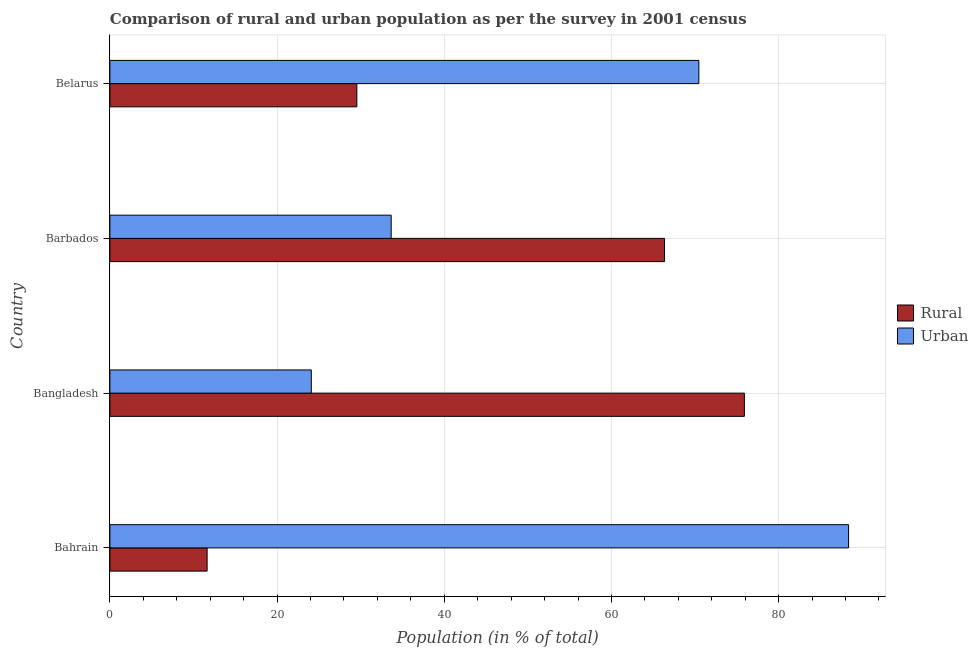Are the number of bars on each tick of the Y-axis equal?
Give a very brief answer. Yes. What is the label of the 1st group of bars from the top?
Provide a succinct answer. Belarus. In how many cases, is the number of bars for a given country not equal to the number of legend labels?
Ensure brevity in your answer.  0. What is the rural population in Bahrain?
Offer a very short reply. 11.63. Across all countries, what is the maximum urban population?
Your answer should be very brief. 88.37. Across all countries, what is the minimum rural population?
Offer a very short reply. 11.63. In which country was the urban population maximum?
Keep it short and to the point. Bahrain. In which country was the rural population minimum?
Your response must be concise. Bahrain. What is the total rural population in the graph?
Keep it short and to the point. 183.43. What is the difference between the urban population in Barbados and that in Belarus?
Provide a succinct answer. -36.81. What is the difference between the urban population in Bangladesh and the rural population in Barbados?
Your answer should be very brief. -42.25. What is the average rural population per country?
Make the answer very short. 45.86. What is the difference between the urban population and rural population in Bangladesh?
Provide a short and direct response. -51.81. What is the ratio of the urban population in Bahrain to that in Bangladesh?
Give a very brief answer. 3.67. Is the urban population in Bangladesh less than that in Belarus?
Your answer should be very brief. Yes. What is the difference between the highest and the second highest urban population?
Provide a short and direct response. 17.91. What is the difference between the highest and the lowest urban population?
Keep it short and to the point. 64.27. What does the 1st bar from the top in Belarus represents?
Your response must be concise. Urban. What does the 2nd bar from the bottom in Barbados represents?
Make the answer very short. Urban. How many bars are there?
Your answer should be compact. 8. Where does the legend appear in the graph?
Make the answer very short. Center right. How are the legend labels stacked?
Offer a very short reply. Vertical. What is the title of the graph?
Keep it short and to the point. Comparison of rural and urban population as per the survey in 2001 census. What is the label or title of the X-axis?
Ensure brevity in your answer.  Population (in % of total). What is the Population (in % of total) of Rural in Bahrain?
Your answer should be very brief. 11.63. What is the Population (in % of total) in Urban in Bahrain?
Your answer should be very brief. 88.37. What is the Population (in % of total) in Rural in Bangladesh?
Your answer should be compact. 75.9. What is the Population (in % of total) in Urban in Bangladesh?
Ensure brevity in your answer.  24.1. What is the Population (in % of total) in Rural in Barbados?
Your response must be concise. 66.35. What is the Population (in % of total) in Urban in Barbados?
Offer a terse response. 33.65. What is the Population (in % of total) in Rural in Belarus?
Keep it short and to the point. 29.54. What is the Population (in % of total) in Urban in Belarus?
Give a very brief answer. 70.46. Across all countries, what is the maximum Population (in % of total) of Rural?
Offer a terse response. 75.9. Across all countries, what is the maximum Population (in % of total) in Urban?
Give a very brief answer. 88.37. Across all countries, what is the minimum Population (in % of total) in Rural?
Give a very brief answer. 11.63. Across all countries, what is the minimum Population (in % of total) of Urban?
Your answer should be compact. 24.1. What is the total Population (in % of total) in Rural in the graph?
Your answer should be compact. 183.43. What is the total Population (in % of total) in Urban in the graph?
Your answer should be compact. 216.57. What is the difference between the Population (in % of total) of Rural in Bahrain and that in Bangladesh?
Provide a short and direct response. -64.27. What is the difference between the Population (in % of total) in Urban in Bahrain and that in Bangladesh?
Make the answer very short. 64.27. What is the difference between the Population (in % of total) in Rural in Bahrain and that in Barbados?
Offer a very short reply. -54.72. What is the difference between the Population (in % of total) of Urban in Bahrain and that in Barbados?
Provide a short and direct response. 54.72. What is the difference between the Population (in % of total) of Rural in Bahrain and that in Belarus?
Ensure brevity in your answer.  -17.91. What is the difference between the Population (in % of total) of Urban in Bahrain and that in Belarus?
Offer a terse response. 17.91. What is the difference between the Population (in % of total) in Rural in Bangladesh and that in Barbados?
Your answer should be compact. 9.55. What is the difference between the Population (in % of total) of Urban in Bangladesh and that in Barbados?
Your answer should be very brief. -9.55. What is the difference between the Population (in % of total) of Rural in Bangladesh and that in Belarus?
Provide a succinct answer. 46.36. What is the difference between the Population (in % of total) in Urban in Bangladesh and that in Belarus?
Offer a terse response. -46.36. What is the difference between the Population (in % of total) of Rural in Barbados and that in Belarus?
Offer a terse response. 36.81. What is the difference between the Population (in % of total) of Urban in Barbados and that in Belarus?
Make the answer very short. -36.81. What is the difference between the Population (in % of total) in Rural in Bahrain and the Population (in % of total) in Urban in Bangladesh?
Your answer should be very brief. -12.46. What is the difference between the Population (in % of total) of Rural in Bahrain and the Population (in % of total) of Urban in Barbados?
Offer a terse response. -22.02. What is the difference between the Population (in % of total) in Rural in Bahrain and the Population (in % of total) in Urban in Belarus?
Give a very brief answer. -58.83. What is the difference between the Population (in % of total) of Rural in Bangladesh and the Population (in % of total) of Urban in Barbados?
Provide a succinct answer. 42.25. What is the difference between the Population (in % of total) of Rural in Bangladesh and the Population (in % of total) of Urban in Belarus?
Offer a terse response. 5.45. What is the difference between the Population (in % of total) in Rural in Barbados and the Population (in % of total) in Urban in Belarus?
Make the answer very short. -4.11. What is the average Population (in % of total) in Rural per country?
Your response must be concise. 45.86. What is the average Population (in % of total) in Urban per country?
Provide a short and direct response. 54.14. What is the difference between the Population (in % of total) in Rural and Population (in % of total) in Urban in Bahrain?
Your response must be concise. -76.74. What is the difference between the Population (in % of total) in Rural and Population (in % of total) in Urban in Bangladesh?
Keep it short and to the point. 51.81. What is the difference between the Population (in % of total) of Rural and Population (in % of total) of Urban in Barbados?
Your response must be concise. 32.7. What is the difference between the Population (in % of total) of Rural and Population (in % of total) of Urban in Belarus?
Give a very brief answer. -40.92. What is the ratio of the Population (in % of total) in Rural in Bahrain to that in Bangladesh?
Make the answer very short. 0.15. What is the ratio of the Population (in % of total) in Urban in Bahrain to that in Bangladesh?
Provide a short and direct response. 3.67. What is the ratio of the Population (in % of total) in Rural in Bahrain to that in Barbados?
Your answer should be very brief. 0.18. What is the ratio of the Population (in % of total) of Urban in Bahrain to that in Barbados?
Your response must be concise. 2.63. What is the ratio of the Population (in % of total) in Rural in Bahrain to that in Belarus?
Your answer should be compact. 0.39. What is the ratio of the Population (in % of total) in Urban in Bahrain to that in Belarus?
Make the answer very short. 1.25. What is the ratio of the Population (in % of total) of Rural in Bangladesh to that in Barbados?
Offer a very short reply. 1.14. What is the ratio of the Population (in % of total) of Urban in Bangladesh to that in Barbados?
Make the answer very short. 0.72. What is the ratio of the Population (in % of total) in Rural in Bangladesh to that in Belarus?
Offer a terse response. 2.57. What is the ratio of the Population (in % of total) of Urban in Bangladesh to that in Belarus?
Ensure brevity in your answer.  0.34. What is the ratio of the Population (in % of total) of Rural in Barbados to that in Belarus?
Your answer should be very brief. 2.25. What is the ratio of the Population (in % of total) in Urban in Barbados to that in Belarus?
Offer a very short reply. 0.48. What is the difference between the highest and the second highest Population (in % of total) in Rural?
Your response must be concise. 9.55. What is the difference between the highest and the second highest Population (in % of total) in Urban?
Ensure brevity in your answer.  17.91. What is the difference between the highest and the lowest Population (in % of total) in Rural?
Give a very brief answer. 64.27. What is the difference between the highest and the lowest Population (in % of total) in Urban?
Ensure brevity in your answer.  64.27. 